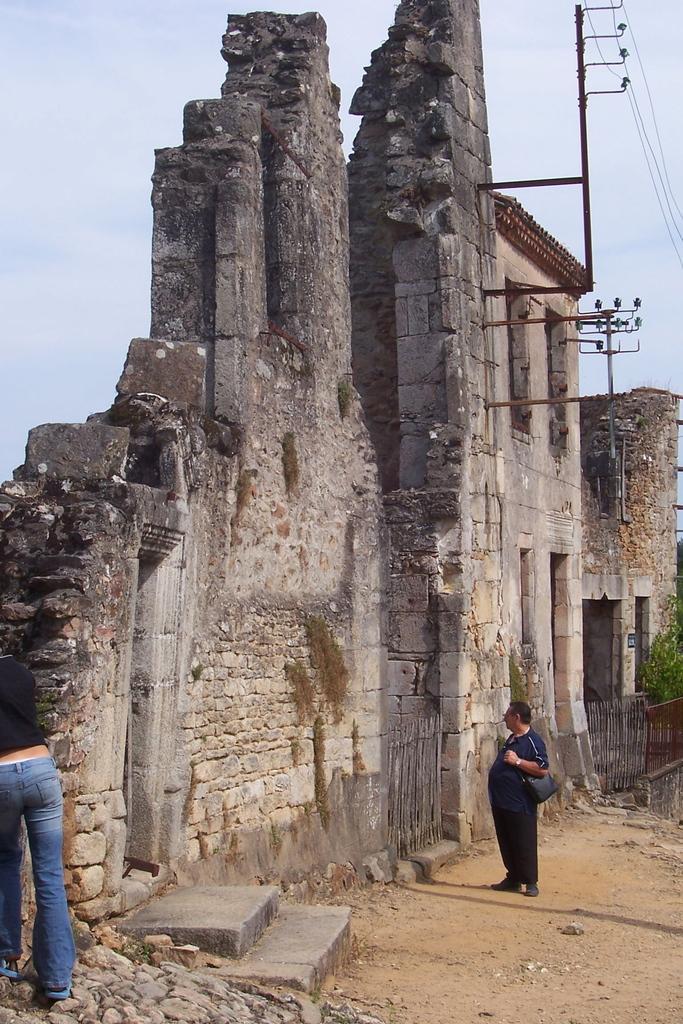Describe this image in one or two sentences. In this image, we can see walls, plants, wooden fencing, rods, few people, stairs, stones and ground. On the right side of the image, a person is standing and wearing a bag. Background there is a sky. Here we can see wires and rods. 